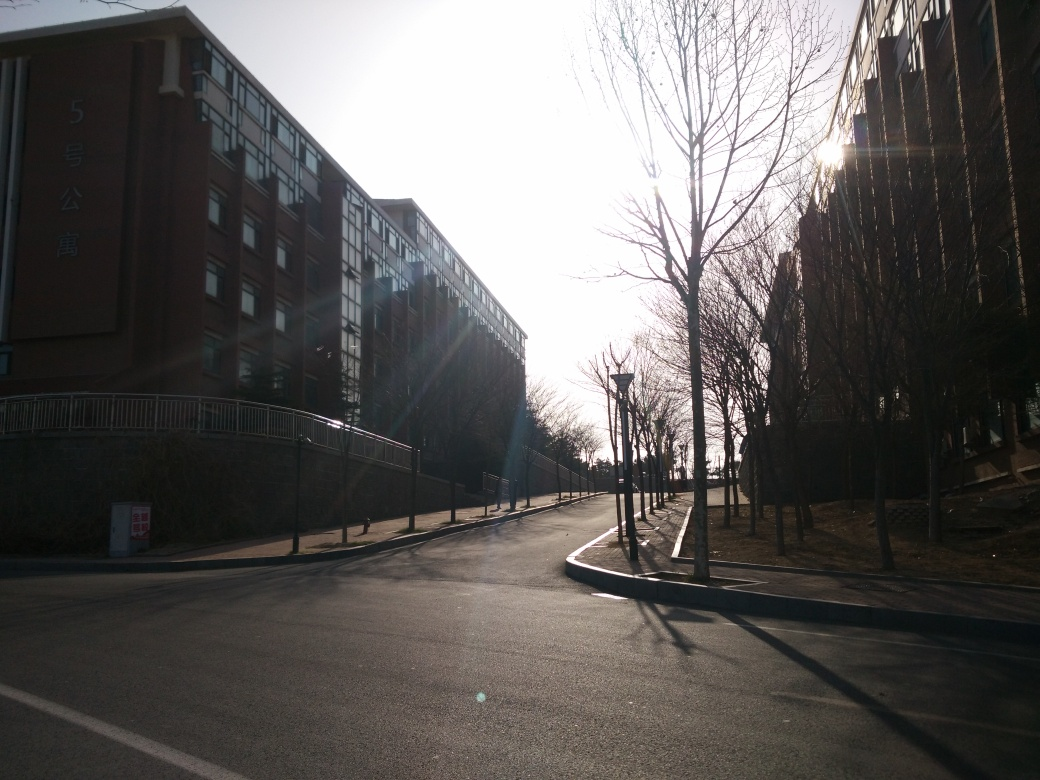What could be improved in this photograph to enhance its visual appeal? To enhance the visual appeal, the photographer could adjust the exposure settings to avoid the overexposed areas around the sun. Using HDR (High Dynamic Range) techniques or shooting at a different time of day could bring out more detail in the shadows and highlights. Additionally, including subjects such as people or vehicles might add life and tell a more compelling story. 